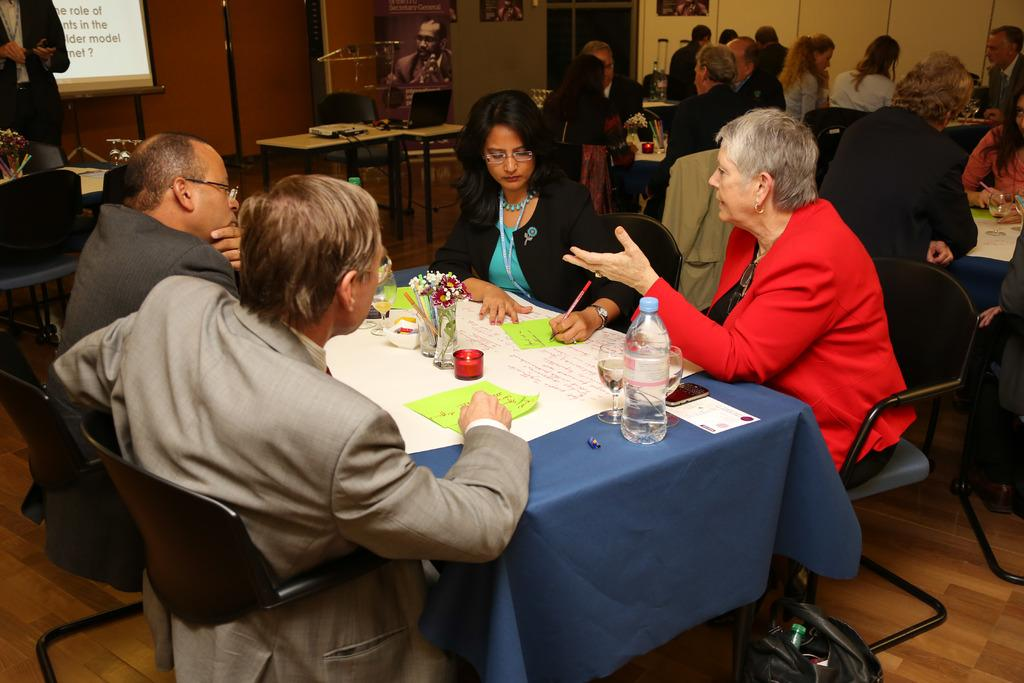How are the people arranged in the image? The people are arranged in groups in the image. How many people are in each group? Each group consists of four members. Where are the groups seated? Each group is seated at a separate table. What type of sheet is being used by the spy in the image? There is no spy or sheet present in the image. What type of competition is taking place between the groups in the image? There is no competition present in the image; the groups are simply seated at separate tables. 